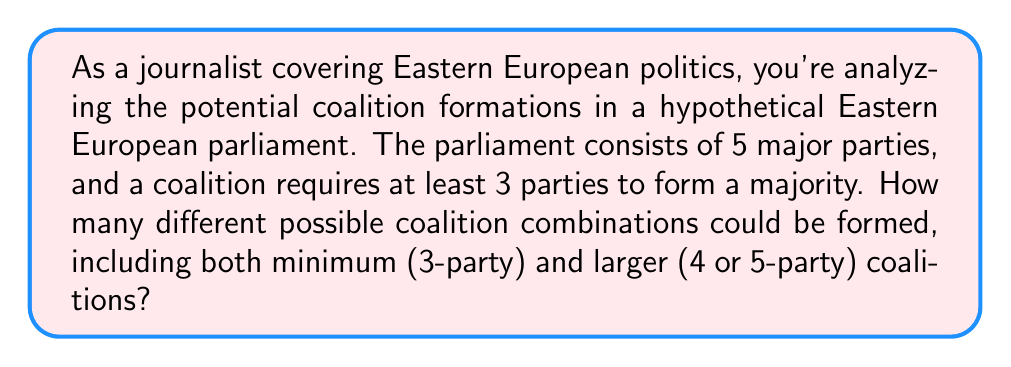Teach me how to tackle this problem. To solve this problem, we need to use the concept of combinations. We're looking for the number of ways to choose at least 3 parties from a total of 5 parties.

1) First, let's calculate the number of 3-party coalitions:
   $${5 \choose 3} = \frac{5!}{3!(5-3)!} = \frac{5 \cdot 4 \cdot 3}{3 \cdot 2 \cdot 1} = 10$$

2) Next, the number of 4-party coalitions:
   $${5 \choose 4} = \frac{5!}{4!(5-4)!} = \frac{5}{1} = 5$$

3) Finally, the number of 5-party coalitions (all parties together):
   $${5 \choose 5} = 1$$

4) The total number of possible coalitions is the sum of all these:

   $$\text{Total} = {5 \choose 3} + {5 \choose 4} + {5 \choose 5} = 10 + 5 + 1 = 16$$

This result can also be derived using the formula for the sum of combinations:

$$\sum_{k=3}^5 {5 \choose k} = {5 \choose 3} + {5 \choose 4} + {5 \choose 5} = 16$$

This formula calculates all combinations of 3 or more parties from a total of 5 parties.
Answer: There are 16 possible coalition combinations in the hypothetical Eastern European parliament. 